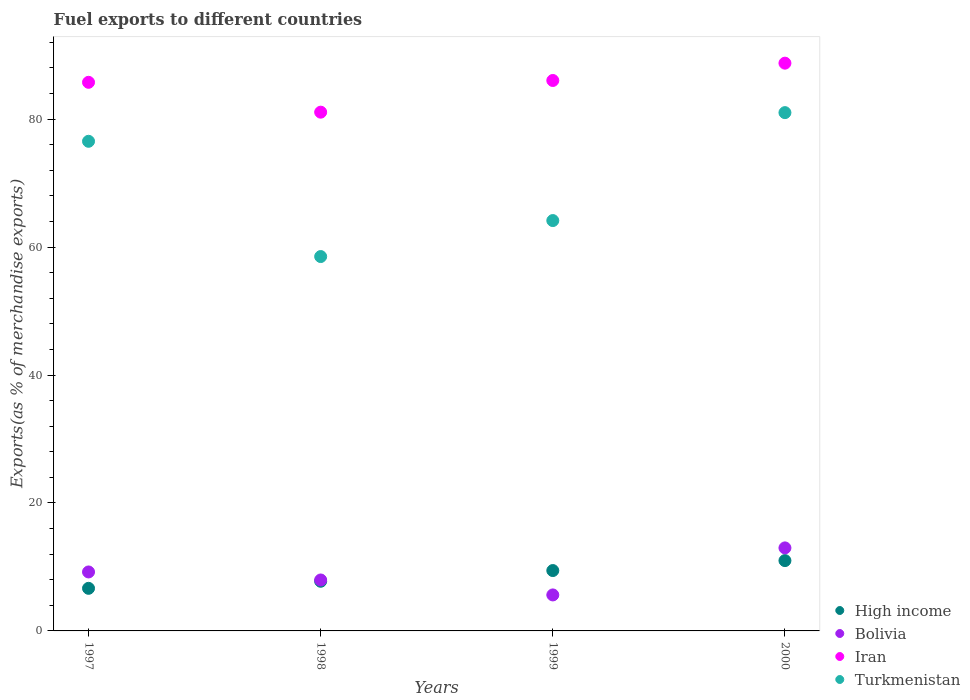How many different coloured dotlines are there?
Keep it short and to the point. 4. What is the percentage of exports to different countries in High income in 1999?
Ensure brevity in your answer.  9.44. Across all years, what is the maximum percentage of exports to different countries in High income?
Give a very brief answer. 10.99. Across all years, what is the minimum percentage of exports to different countries in Iran?
Offer a very short reply. 81.08. In which year was the percentage of exports to different countries in Bolivia maximum?
Ensure brevity in your answer.  2000. What is the total percentage of exports to different countries in Turkmenistan in the graph?
Provide a short and direct response. 280.19. What is the difference between the percentage of exports to different countries in High income in 1998 and that in 2000?
Ensure brevity in your answer.  -3.23. What is the difference between the percentage of exports to different countries in Iran in 1998 and the percentage of exports to different countries in Turkmenistan in 2000?
Offer a very short reply. 0.07. What is the average percentage of exports to different countries in Bolivia per year?
Offer a very short reply. 8.95. In the year 2000, what is the difference between the percentage of exports to different countries in Turkmenistan and percentage of exports to different countries in Iran?
Keep it short and to the point. -7.73. In how many years, is the percentage of exports to different countries in Iran greater than 48 %?
Give a very brief answer. 4. What is the ratio of the percentage of exports to different countries in Turkmenistan in 1998 to that in 1999?
Offer a terse response. 0.91. What is the difference between the highest and the second highest percentage of exports to different countries in High income?
Your answer should be compact. 1.56. What is the difference between the highest and the lowest percentage of exports to different countries in Bolivia?
Your answer should be compact. 7.35. In how many years, is the percentage of exports to different countries in Bolivia greater than the average percentage of exports to different countries in Bolivia taken over all years?
Offer a very short reply. 2. Is the sum of the percentage of exports to different countries in High income in 1998 and 1999 greater than the maximum percentage of exports to different countries in Bolivia across all years?
Offer a terse response. Yes. Does the percentage of exports to different countries in Turkmenistan monotonically increase over the years?
Ensure brevity in your answer.  No. Is the percentage of exports to different countries in Turkmenistan strictly greater than the percentage of exports to different countries in Bolivia over the years?
Ensure brevity in your answer.  Yes. Are the values on the major ticks of Y-axis written in scientific E-notation?
Your response must be concise. No. Where does the legend appear in the graph?
Your answer should be very brief. Bottom right. What is the title of the graph?
Keep it short and to the point. Fuel exports to different countries. Does "Jamaica" appear as one of the legend labels in the graph?
Your answer should be very brief. No. What is the label or title of the Y-axis?
Make the answer very short. Exports(as % of merchandise exports). What is the Exports(as % of merchandise exports) in High income in 1997?
Your answer should be compact. 6.66. What is the Exports(as % of merchandise exports) of Bolivia in 1997?
Make the answer very short. 9.22. What is the Exports(as % of merchandise exports) of Iran in 1997?
Your response must be concise. 85.75. What is the Exports(as % of merchandise exports) of Turkmenistan in 1997?
Offer a terse response. 76.53. What is the Exports(as % of merchandise exports) in High income in 1998?
Provide a succinct answer. 7.76. What is the Exports(as % of merchandise exports) in Bolivia in 1998?
Keep it short and to the point. 7.96. What is the Exports(as % of merchandise exports) of Iran in 1998?
Provide a short and direct response. 81.08. What is the Exports(as % of merchandise exports) of Turkmenistan in 1998?
Give a very brief answer. 58.51. What is the Exports(as % of merchandise exports) in High income in 1999?
Provide a succinct answer. 9.44. What is the Exports(as % of merchandise exports) in Bolivia in 1999?
Offer a terse response. 5.63. What is the Exports(as % of merchandise exports) in Iran in 1999?
Provide a short and direct response. 86.04. What is the Exports(as % of merchandise exports) in Turkmenistan in 1999?
Your response must be concise. 64.14. What is the Exports(as % of merchandise exports) of High income in 2000?
Give a very brief answer. 10.99. What is the Exports(as % of merchandise exports) of Bolivia in 2000?
Offer a very short reply. 12.98. What is the Exports(as % of merchandise exports) in Iran in 2000?
Your response must be concise. 88.74. What is the Exports(as % of merchandise exports) in Turkmenistan in 2000?
Ensure brevity in your answer.  81.01. Across all years, what is the maximum Exports(as % of merchandise exports) in High income?
Provide a short and direct response. 10.99. Across all years, what is the maximum Exports(as % of merchandise exports) in Bolivia?
Offer a terse response. 12.98. Across all years, what is the maximum Exports(as % of merchandise exports) in Iran?
Provide a short and direct response. 88.74. Across all years, what is the maximum Exports(as % of merchandise exports) of Turkmenistan?
Offer a very short reply. 81.01. Across all years, what is the minimum Exports(as % of merchandise exports) of High income?
Your answer should be very brief. 6.66. Across all years, what is the minimum Exports(as % of merchandise exports) in Bolivia?
Your answer should be compact. 5.63. Across all years, what is the minimum Exports(as % of merchandise exports) of Iran?
Make the answer very short. 81.08. Across all years, what is the minimum Exports(as % of merchandise exports) in Turkmenistan?
Your answer should be very brief. 58.51. What is the total Exports(as % of merchandise exports) of High income in the graph?
Provide a short and direct response. 34.85. What is the total Exports(as % of merchandise exports) of Bolivia in the graph?
Offer a terse response. 35.78. What is the total Exports(as % of merchandise exports) in Iran in the graph?
Offer a terse response. 341.61. What is the total Exports(as % of merchandise exports) of Turkmenistan in the graph?
Your answer should be compact. 280.19. What is the difference between the Exports(as % of merchandise exports) in High income in 1997 and that in 1998?
Offer a very short reply. -1.1. What is the difference between the Exports(as % of merchandise exports) of Bolivia in 1997 and that in 1998?
Your response must be concise. 1.25. What is the difference between the Exports(as % of merchandise exports) of Iran in 1997 and that in 1998?
Offer a very short reply. 4.67. What is the difference between the Exports(as % of merchandise exports) in Turkmenistan in 1997 and that in 1998?
Provide a short and direct response. 18.02. What is the difference between the Exports(as % of merchandise exports) in High income in 1997 and that in 1999?
Your response must be concise. -2.78. What is the difference between the Exports(as % of merchandise exports) of Bolivia in 1997 and that in 1999?
Your response must be concise. 3.59. What is the difference between the Exports(as % of merchandise exports) in Iran in 1997 and that in 1999?
Offer a terse response. -0.29. What is the difference between the Exports(as % of merchandise exports) of Turkmenistan in 1997 and that in 1999?
Your answer should be very brief. 12.39. What is the difference between the Exports(as % of merchandise exports) of High income in 1997 and that in 2000?
Ensure brevity in your answer.  -4.33. What is the difference between the Exports(as % of merchandise exports) of Bolivia in 1997 and that in 2000?
Provide a short and direct response. -3.76. What is the difference between the Exports(as % of merchandise exports) in Iran in 1997 and that in 2000?
Keep it short and to the point. -2.99. What is the difference between the Exports(as % of merchandise exports) of Turkmenistan in 1997 and that in 2000?
Your answer should be compact. -4.48. What is the difference between the Exports(as % of merchandise exports) of High income in 1998 and that in 1999?
Provide a short and direct response. -1.67. What is the difference between the Exports(as % of merchandise exports) of Bolivia in 1998 and that in 1999?
Make the answer very short. 2.34. What is the difference between the Exports(as % of merchandise exports) in Iran in 1998 and that in 1999?
Offer a terse response. -4.95. What is the difference between the Exports(as % of merchandise exports) of Turkmenistan in 1998 and that in 1999?
Provide a short and direct response. -5.62. What is the difference between the Exports(as % of merchandise exports) of High income in 1998 and that in 2000?
Offer a very short reply. -3.23. What is the difference between the Exports(as % of merchandise exports) of Bolivia in 1998 and that in 2000?
Your response must be concise. -5.01. What is the difference between the Exports(as % of merchandise exports) in Iran in 1998 and that in 2000?
Offer a terse response. -7.66. What is the difference between the Exports(as % of merchandise exports) in Turkmenistan in 1998 and that in 2000?
Your answer should be very brief. -22.5. What is the difference between the Exports(as % of merchandise exports) in High income in 1999 and that in 2000?
Offer a very short reply. -1.56. What is the difference between the Exports(as % of merchandise exports) of Bolivia in 1999 and that in 2000?
Offer a very short reply. -7.35. What is the difference between the Exports(as % of merchandise exports) in Iran in 1999 and that in 2000?
Keep it short and to the point. -2.71. What is the difference between the Exports(as % of merchandise exports) of Turkmenistan in 1999 and that in 2000?
Provide a succinct answer. -16.87. What is the difference between the Exports(as % of merchandise exports) in High income in 1997 and the Exports(as % of merchandise exports) in Bolivia in 1998?
Offer a very short reply. -1.31. What is the difference between the Exports(as % of merchandise exports) of High income in 1997 and the Exports(as % of merchandise exports) of Iran in 1998?
Keep it short and to the point. -74.43. What is the difference between the Exports(as % of merchandise exports) of High income in 1997 and the Exports(as % of merchandise exports) of Turkmenistan in 1998?
Your response must be concise. -51.86. What is the difference between the Exports(as % of merchandise exports) in Bolivia in 1997 and the Exports(as % of merchandise exports) in Iran in 1998?
Your response must be concise. -71.87. What is the difference between the Exports(as % of merchandise exports) in Bolivia in 1997 and the Exports(as % of merchandise exports) in Turkmenistan in 1998?
Offer a very short reply. -49.3. What is the difference between the Exports(as % of merchandise exports) in Iran in 1997 and the Exports(as % of merchandise exports) in Turkmenistan in 1998?
Make the answer very short. 27.23. What is the difference between the Exports(as % of merchandise exports) in High income in 1997 and the Exports(as % of merchandise exports) in Bolivia in 1999?
Ensure brevity in your answer.  1.03. What is the difference between the Exports(as % of merchandise exports) in High income in 1997 and the Exports(as % of merchandise exports) in Iran in 1999?
Offer a terse response. -79.38. What is the difference between the Exports(as % of merchandise exports) in High income in 1997 and the Exports(as % of merchandise exports) in Turkmenistan in 1999?
Provide a succinct answer. -57.48. What is the difference between the Exports(as % of merchandise exports) of Bolivia in 1997 and the Exports(as % of merchandise exports) of Iran in 1999?
Offer a terse response. -76.82. What is the difference between the Exports(as % of merchandise exports) of Bolivia in 1997 and the Exports(as % of merchandise exports) of Turkmenistan in 1999?
Keep it short and to the point. -54.92. What is the difference between the Exports(as % of merchandise exports) of Iran in 1997 and the Exports(as % of merchandise exports) of Turkmenistan in 1999?
Keep it short and to the point. 21.61. What is the difference between the Exports(as % of merchandise exports) of High income in 1997 and the Exports(as % of merchandise exports) of Bolivia in 2000?
Offer a terse response. -6.32. What is the difference between the Exports(as % of merchandise exports) in High income in 1997 and the Exports(as % of merchandise exports) in Iran in 2000?
Offer a terse response. -82.08. What is the difference between the Exports(as % of merchandise exports) in High income in 1997 and the Exports(as % of merchandise exports) in Turkmenistan in 2000?
Keep it short and to the point. -74.35. What is the difference between the Exports(as % of merchandise exports) in Bolivia in 1997 and the Exports(as % of merchandise exports) in Iran in 2000?
Your answer should be very brief. -79.53. What is the difference between the Exports(as % of merchandise exports) of Bolivia in 1997 and the Exports(as % of merchandise exports) of Turkmenistan in 2000?
Your answer should be compact. -71.79. What is the difference between the Exports(as % of merchandise exports) of Iran in 1997 and the Exports(as % of merchandise exports) of Turkmenistan in 2000?
Your answer should be very brief. 4.74. What is the difference between the Exports(as % of merchandise exports) in High income in 1998 and the Exports(as % of merchandise exports) in Bolivia in 1999?
Your answer should be compact. 2.14. What is the difference between the Exports(as % of merchandise exports) of High income in 1998 and the Exports(as % of merchandise exports) of Iran in 1999?
Give a very brief answer. -78.27. What is the difference between the Exports(as % of merchandise exports) of High income in 1998 and the Exports(as % of merchandise exports) of Turkmenistan in 1999?
Your answer should be compact. -56.38. What is the difference between the Exports(as % of merchandise exports) in Bolivia in 1998 and the Exports(as % of merchandise exports) in Iran in 1999?
Provide a succinct answer. -78.07. What is the difference between the Exports(as % of merchandise exports) of Bolivia in 1998 and the Exports(as % of merchandise exports) of Turkmenistan in 1999?
Provide a short and direct response. -56.18. What is the difference between the Exports(as % of merchandise exports) of Iran in 1998 and the Exports(as % of merchandise exports) of Turkmenistan in 1999?
Offer a terse response. 16.94. What is the difference between the Exports(as % of merchandise exports) of High income in 1998 and the Exports(as % of merchandise exports) of Bolivia in 2000?
Give a very brief answer. -5.21. What is the difference between the Exports(as % of merchandise exports) in High income in 1998 and the Exports(as % of merchandise exports) in Iran in 2000?
Give a very brief answer. -80.98. What is the difference between the Exports(as % of merchandise exports) of High income in 1998 and the Exports(as % of merchandise exports) of Turkmenistan in 2000?
Provide a short and direct response. -73.25. What is the difference between the Exports(as % of merchandise exports) in Bolivia in 1998 and the Exports(as % of merchandise exports) in Iran in 2000?
Give a very brief answer. -80.78. What is the difference between the Exports(as % of merchandise exports) of Bolivia in 1998 and the Exports(as % of merchandise exports) of Turkmenistan in 2000?
Your answer should be compact. -73.05. What is the difference between the Exports(as % of merchandise exports) of Iran in 1998 and the Exports(as % of merchandise exports) of Turkmenistan in 2000?
Make the answer very short. 0.07. What is the difference between the Exports(as % of merchandise exports) of High income in 1999 and the Exports(as % of merchandise exports) of Bolivia in 2000?
Your answer should be compact. -3.54. What is the difference between the Exports(as % of merchandise exports) in High income in 1999 and the Exports(as % of merchandise exports) in Iran in 2000?
Offer a very short reply. -79.31. What is the difference between the Exports(as % of merchandise exports) in High income in 1999 and the Exports(as % of merchandise exports) in Turkmenistan in 2000?
Your response must be concise. -71.57. What is the difference between the Exports(as % of merchandise exports) in Bolivia in 1999 and the Exports(as % of merchandise exports) in Iran in 2000?
Make the answer very short. -83.12. What is the difference between the Exports(as % of merchandise exports) of Bolivia in 1999 and the Exports(as % of merchandise exports) of Turkmenistan in 2000?
Keep it short and to the point. -75.38. What is the difference between the Exports(as % of merchandise exports) in Iran in 1999 and the Exports(as % of merchandise exports) in Turkmenistan in 2000?
Offer a terse response. 5.03. What is the average Exports(as % of merchandise exports) of High income per year?
Offer a terse response. 8.71. What is the average Exports(as % of merchandise exports) of Bolivia per year?
Offer a terse response. 8.95. What is the average Exports(as % of merchandise exports) of Iran per year?
Offer a terse response. 85.4. What is the average Exports(as % of merchandise exports) in Turkmenistan per year?
Give a very brief answer. 70.05. In the year 1997, what is the difference between the Exports(as % of merchandise exports) in High income and Exports(as % of merchandise exports) in Bolivia?
Your answer should be compact. -2.56. In the year 1997, what is the difference between the Exports(as % of merchandise exports) of High income and Exports(as % of merchandise exports) of Iran?
Provide a succinct answer. -79.09. In the year 1997, what is the difference between the Exports(as % of merchandise exports) of High income and Exports(as % of merchandise exports) of Turkmenistan?
Offer a very short reply. -69.87. In the year 1997, what is the difference between the Exports(as % of merchandise exports) of Bolivia and Exports(as % of merchandise exports) of Iran?
Keep it short and to the point. -76.53. In the year 1997, what is the difference between the Exports(as % of merchandise exports) of Bolivia and Exports(as % of merchandise exports) of Turkmenistan?
Give a very brief answer. -67.31. In the year 1997, what is the difference between the Exports(as % of merchandise exports) in Iran and Exports(as % of merchandise exports) in Turkmenistan?
Give a very brief answer. 9.22. In the year 1998, what is the difference between the Exports(as % of merchandise exports) in High income and Exports(as % of merchandise exports) in Bolivia?
Offer a very short reply. -0.2. In the year 1998, what is the difference between the Exports(as % of merchandise exports) in High income and Exports(as % of merchandise exports) in Iran?
Your response must be concise. -73.32. In the year 1998, what is the difference between the Exports(as % of merchandise exports) of High income and Exports(as % of merchandise exports) of Turkmenistan?
Your answer should be very brief. -50.75. In the year 1998, what is the difference between the Exports(as % of merchandise exports) of Bolivia and Exports(as % of merchandise exports) of Iran?
Your answer should be compact. -73.12. In the year 1998, what is the difference between the Exports(as % of merchandise exports) in Bolivia and Exports(as % of merchandise exports) in Turkmenistan?
Offer a very short reply. -50.55. In the year 1998, what is the difference between the Exports(as % of merchandise exports) in Iran and Exports(as % of merchandise exports) in Turkmenistan?
Your response must be concise. 22.57. In the year 1999, what is the difference between the Exports(as % of merchandise exports) in High income and Exports(as % of merchandise exports) in Bolivia?
Ensure brevity in your answer.  3.81. In the year 1999, what is the difference between the Exports(as % of merchandise exports) in High income and Exports(as % of merchandise exports) in Iran?
Your answer should be compact. -76.6. In the year 1999, what is the difference between the Exports(as % of merchandise exports) of High income and Exports(as % of merchandise exports) of Turkmenistan?
Ensure brevity in your answer.  -54.7. In the year 1999, what is the difference between the Exports(as % of merchandise exports) of Bolivia and Exports(as % of merchandise exports) of Iran?
Ensure brevity in your answer.  -80.41. In the year 1999, what is the difference between the Exports(as % of merchandise exports) of Bolivia and Exports(as % of merchandise exports) of Turkmenistan?
Your answer should be very brief. -58.51. In the year 1999, what is the difference between the Exports(as % of merchandise exports) of Iran and Exports(as % of merchandise exports) of Turkmenistan?
Offer a very short reply. 21.9. In the year 2000, what is the difference between the Exports(as % of merchandise exports) of High income and Exports(as % of merchandise exports) of Bolivia?
Offer a very short reply. -1.99. In the year 2000, what is the difference between the Exports(as % of merchandise exports) in High income and Exports(as % of merchandise exports) in Iran?
Make the answer very short. -77.75. In the year 2000, what is the difference between the Exports(as % of merchandise exports) of High income and Exports(as % of merchandise exports) of Turkmenistan?
Provide a succinct answer. -70.02. In the year 2000, what is the difference between the Exports(as % of merchandise exports) in Bolivia and Exports(as % of merchandise exports) in Iran?
Offer a very short reply. -75.77. In the year 2000, what is the difference between the Exports(as % of merchandise exports) in Bolivia and Exports(as % of merchandise exports) in Turkmenistan?
Provide a succinct answer. -68.03. In the year 2000, what is the difference between the Exports(as % of merchandise exports) in Iran and Exports(as % of merchandise exports) in Turkmenistan?
Offer a very short reply. 7.73. What is the ratio of the Exports(as % of merchandise exports) in High income in 1997 to that in 1998?
Provide a succinct answer. 0.86. What is the ratio of the Exports(as % of merchandise exports) of Bolivia in 1997 to that in 1998?
Your answer should be very brief. 1.16. What is the ratio of the Exports(as % of merchandise exports) of Iran in 1997 to that in 1998?
Offer a terse response. 1.06. What is the ratio of the Exports(as % of merchandise exports) of Turkmenistan in 1997 to that in 1998?
Keep it short and to the point. 1.31. What is the ratio of the Exports(as % of merchandise exports) of High income in 1997 to that in 1999?
Offer a very short reply. 0.71. What is the ratio of the Exports(as % of merchandise exports) in Bolivia in 1997 to that in 1999?
Give a very brief answer. 1.64. What is the ratio of the Exports(as % of merchandise exports) in Iran in 1997 to that in 1999?
Your response must be concise. 1. What is the ratio of the Exports(as % of merchandise exports) in Turkmenistan in 1997 to that in 1999?
Keep it short and to the point. 1.19. What is the ratio of the Exports(as % of merchandise exports) in High income in 1997 to that in 2000?
Your answer should be very brief. 0.61. What is the ratio of the Exports(as % of merchandise exports) of Bolivia in 1997 to that in 2000?
Keep it short and to the point. 0.71. What is the ratio of the Exports(as % of merchandise exports) in Iran in 1997 to that in 2000?
Offer a terse response. 0.97. What is the ratio of the Exports(as % of merchandise exports) in Turkmenistan in 1997 to that in 2000?
Give a very brief answer. 0.94. What is the ratio of the Exports(as % of merchandise exports) in High income in 1998 to that in 1999?
Make the answer very short. 0.82. What is the ratio of the Exports(as % of merchandise exports) in Bolivia in 1998 to that in 1999?
Provide a succinct answer. 1.42. What is the ratio of the Exports(as % of merchandise exports) of Iran in 1998 to that in 1999?
Provide a succinct answer. 0.94. What is the ratio of the Exports(as % of merchandise exports) of Turkmenistan in 1998 to that in 1999?
Your answer should be compact. 0.91. What is the ratio of the Exports(as % of merchandise exports) of High income in 1998 to that in 2000?
Offer a very short reply. 0.71. What is the ratio of the Exports(as % of merchandise exports) in Bolivia in 1998 to that in 2000?
Make the answer very short. 0.61. What is the ratio of the Exports(as % of merchandise exports) of Iran in 1998 to that in 2000?
Keep it short and to the point. 0.91. What is the ratio of the Exports(as % of merchandise exports) of Turkmenistan in 1998 to that in 2000?
Your answer should be compact. 0.72. What is the ratio of the Exports(as % of merchandise exports) of High income in 1999 to that in 2000?
Provide a short and direct response. 0.86. What is the ratio of the Exports(as % of merchandise exports) of Bolivia in 1999 to that in 2000?
Your answer should be compact. 0.43. What is the ratio of the Exports(as % of merchandise exports) in Iran in 1999 to that in 2000?
Keep it short and to the point. 0.97. What is the ratio of the Exports(as % of merchandise exports) of Turkmenistan in 1999 to that in 2000?
Keep it short and to the point. 0.79. What is the difference between the highest and the second highest Exports(as % of merchandise exports) of High income?
Keep it short and to the point. 1.56. What is the difference between the highest and the second highest Exports(as % of merchandise exports) of Bolivia?
Make the answer very short. 3.76. What is the difference between the highest and the second highest Exports(as % of merchandise exports) in Iran?
Offer a terse response. 2.71. What is the difference between the highest and the second highest Exports(as % of merchandise exports) in Turkmenistan?
Offer a terse response. 4.48. What is the difference between the highest and the lowest Exports(as % of merchandise exports) in High income?
Ensure brevity in your answer.  4.33. What is the difference between the highest and the lowest Exports(as % of merchandise exports) of Bolivia?
Offer a terse response. 7.35. What is the difference between the highest and the lowest Exports(as % of merchandise exports) in Iran?
Your answer should be very brief. 7.66. What is the difference between the highest and the lowest Exports(as % of merchandise exports) of Turkmenistan?
Your answer should be compact. 22.5. 